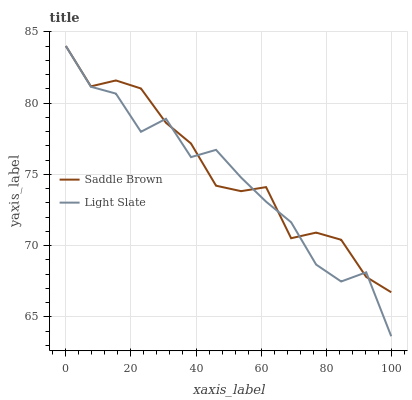Does Light Slate have the minimum area under the curve?
Answer yes or no. Yes. Does Saddle Brown have the maximum area under the curve?
Answer yes or no. Yes. Does Saddle Brown have the minimum area under the curve?
Answer yes or no. No. Is Saddle Brown the smoothest?
Answer yes or no. Yes. Is Light Slate the roughest?
Answer yes or no. Yes. Is Saddle Brown the roughest?
Answer yes or no. No. Does Light Slate have the lowest value?
Answer yes or no. Yes. Does Saddle Brown have the lowest value?
Answer yes or no. No. Does Saddle Brown have the highest value?
Answer yes or no. Yes. Does Saddle Brown intersect Light Slate?
Answer yes or no. Yes. Is Saddle Brown less than Light Slate?
Answer yes or no. No. Is Saddle Brown greater than Light Slate?
Answer yes or no. No. 